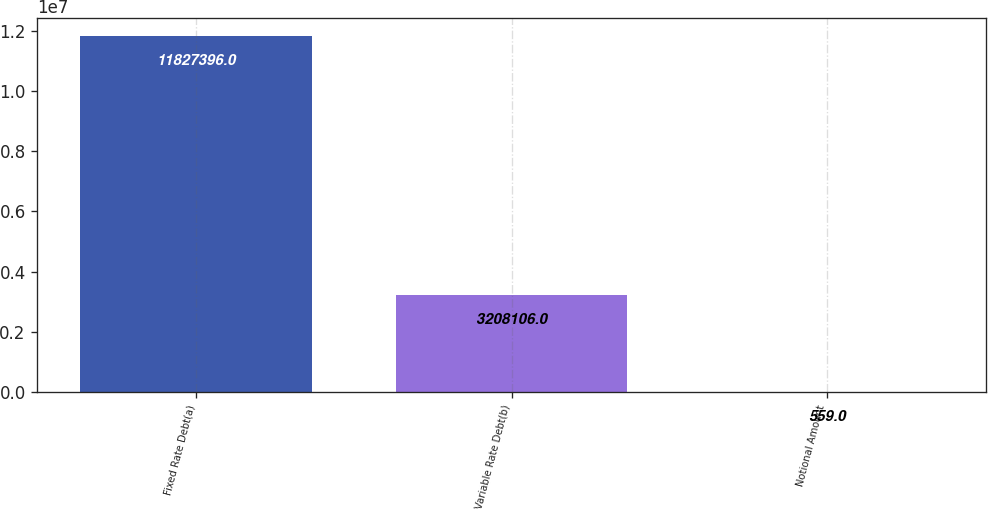Convert chart to OTSL. <chart><loc_0><loc_0><loc_500><loc_500><bar_chart><fcel>Fixed Rate Debt(a)<fcel>Variable Rate Debt(b)<fcel>Notional Amount<nl><fcel>1.18274e+07<fcel>3.20811e+06<fcel>559<nl></chart> 